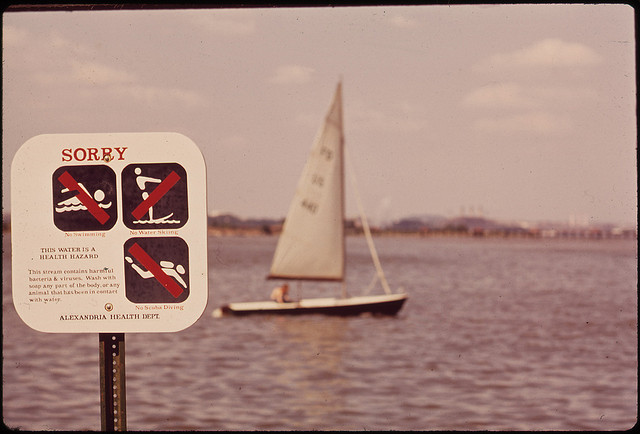Please identify all text content in this image. THIS WATER IS A ILAZARD ALEXANDRIA HEALTH DEPT Diving SORRY 